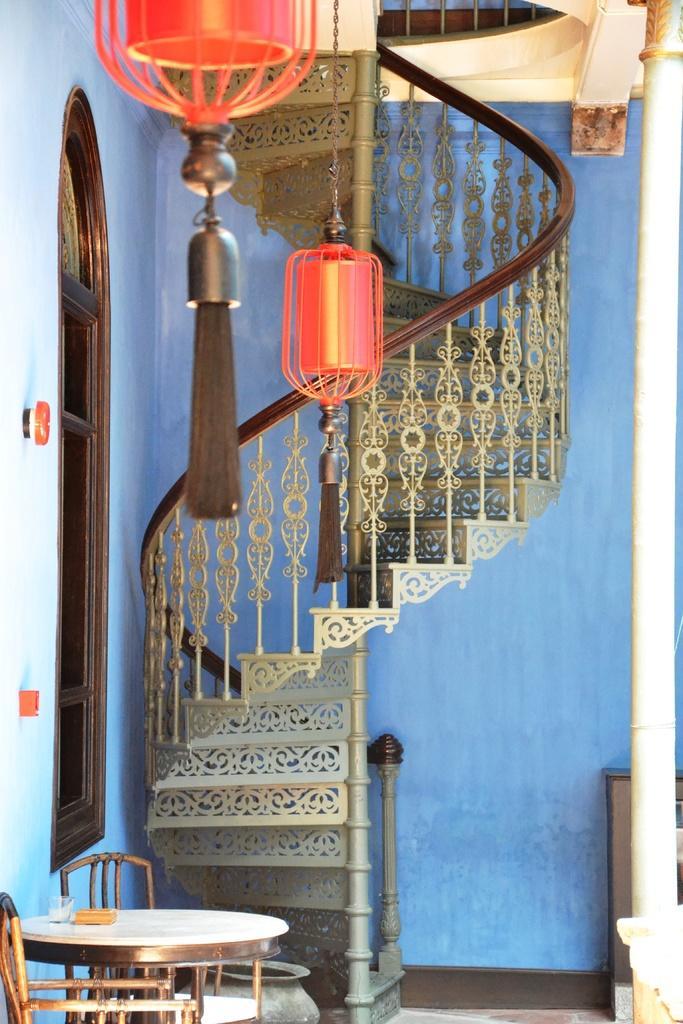Please provide a concise description of this image. In the center of the image we can see stairs. At the top there are decors. At the bottom there is a table and chairs and we can see a vessel. In the background there is a wall and a window. 